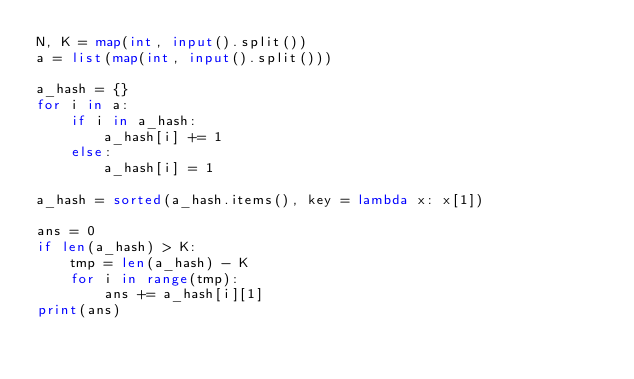Convert code to text. <code><loc_0><loc_0><loc_500><loc_500><_Python_>N, K = map(int, input().split())
a = list(map(int, input().split()))

a_hash = {}
for i in a:
    if i in a_hash:
        a_hash[i] += 1
    else:
        a_hash[i] = 1

a_hash = sorted(a_hash.items(), key = lambda x: x[1])

ans = 0
if len(a_hash) > K:
    tmp = len(a_hash) - K
    for i in range(tmp):
        ans += a_hash[i][1]
print(ans)</code> 